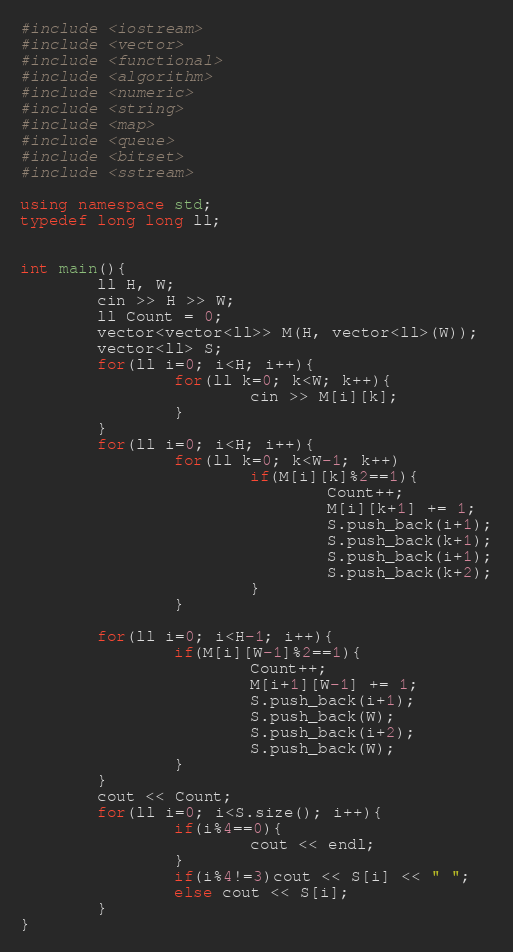<code> <loc_0><loc_0><loc_500><loc_500><_C++_>#include <iostream>
#include <vector>
#include <functional>
#include <algorithm>
#include <numeric>
#include <string>
#include <map>
#include <queue>
#include <bitset>
#include <sstream>

using namespace std;
typedef long long ll;


int main(){
        ll H, W;
        cin >> H >> W;
        ll Count = 0;
        vector<vector<ll>> M(H, vector<ll>(W));
        vector<ll> S;
        for(ll i=0; i<H; i++){
                for(ll k=0; k<W; k++){
                        cin >> M[i][k];
                }
        }
        for(ll i=0; i<H; i++){
                for(ll k=0; k<W-1; k++)
                        if(M[i][k]%2==1){
                                Count++;
                                M[i][k+1] += 1;
                                S.push_back(i+1);
                                S.push_back(k+1);
                                S.push_back(i+1);
                                S.push_back(k+2);
                        }
                }

        for(ll i=0; i<H-1; i++){
                if(M[i][W-1]%2==1){
                        Count++;
                        M[i+1][W-1] += 1;
                        S.push_back(i+1);
                        S.push_back(W);
                        S.push_back(i+2);
                        S.push_back(W);
                }
        }
        cout << Count;
        for(ll i=0; i<S.size(); i++){
                if(i%4==0){
                        cout << endl;
                }
                if(i%4!=3)cout << S[i] << " ";
                else cout << S[i];
        }
}
</code> 